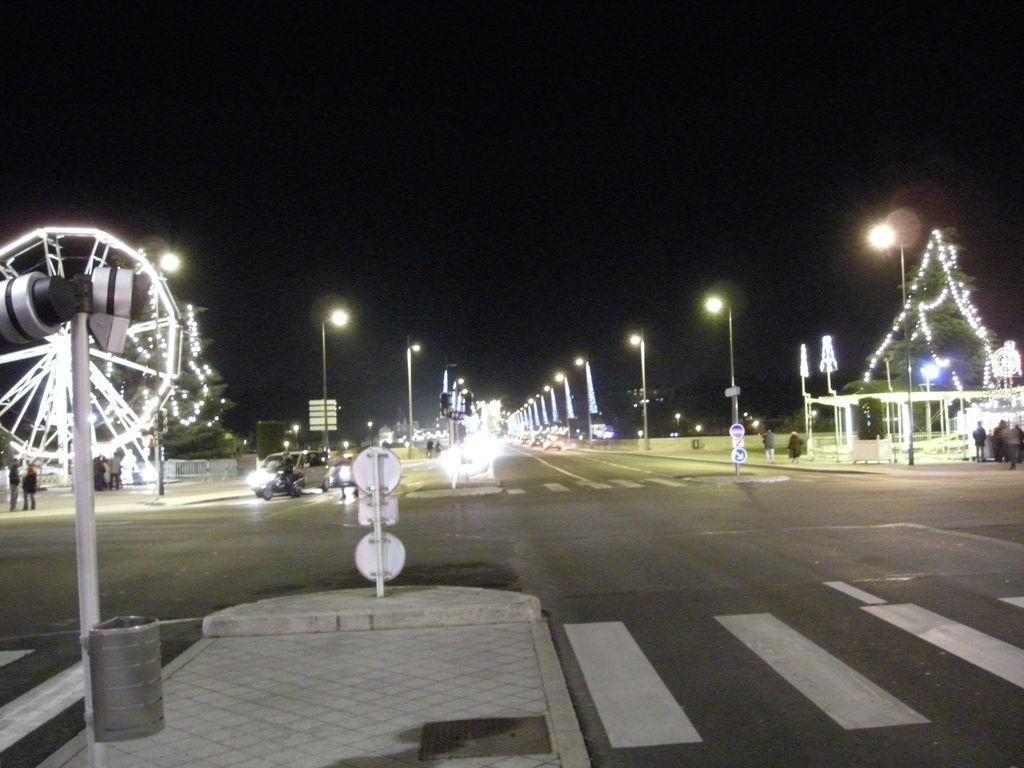Could you give a brief overview of what you see in this image? In this picture we can see a 4 way road with vehicles on it. On the footpath and on the sideways we have many lights and sign boards. 